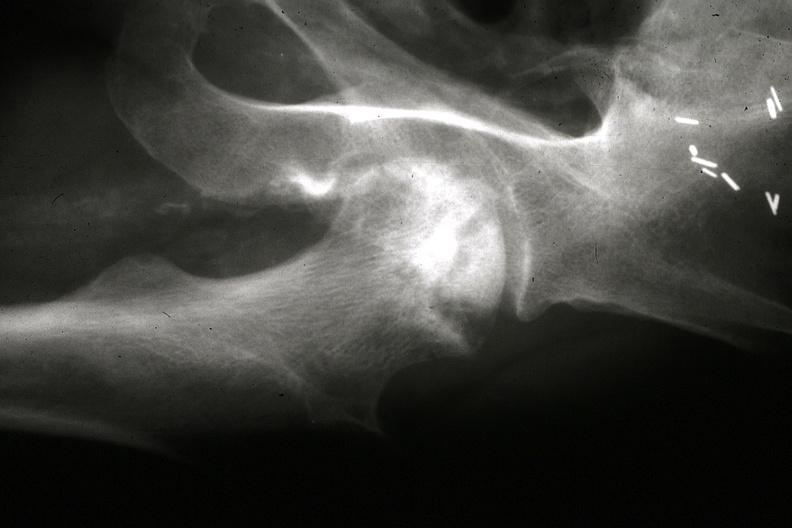how are x-ray close-up of right femoral head from pelvic x-ray gross and x-rays in slides?
Answer the question using a single word or phrase. Other 